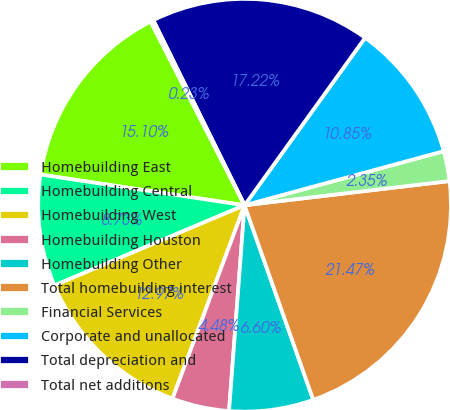Convert chart. <chart><loc_0><loc_0><loc_500><loc_500><pie_chart><fcel>Homebuilding East<fcel>Homebuilding Central<fcel>Homebuilding West<fcel>Homebuilding Houston<fcel>Homebuilding Other<fcel>Total homebuilding interest<fcel>Financial Services<fcel>Corporate and unallocated<fcel>Total depreciation and<fcel>Total net additions<nl><fcel>15.1%<fcel>8.73%<fcel>12.97%<fcel>4.48%<fcel>6.6%<fcel>21.47%<fcel>2.35%<fcel>10.85%<fcel>17.22%<fcel>0.23%<nl></chart> 